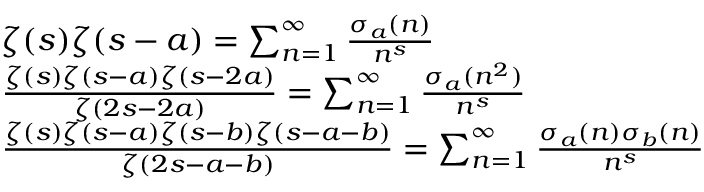<formula> <loc_0><loc_0><loc_500><loc_500>{ \begin{array} { r l } & { \zeta ( s ) \zeta ( s - a ) = \sum _ { n = 1 } ^ { \infty } { \frac { \sigma _ { a } ( n ) } { n ^ { s } } } } \\ & { { \frac { \zeta ( s ) \zeta ( s - a ) \zeta ( s - 2 a ) } { \zeta ( 2 s - 2 a ) } } = \sum _ { n = 1 } ^ { \infty } { \frac { \sigma _ { a } ( n ^ { 2 } ) } { n ^ { s } } } } \\ & { { \frac { \zeta ( s ) \zeta ( s - a ) \zeta ( s - b ) \zeta ( s - a - b ) } { \zeta ( 2 s - a - b ) } } = \sum _ { n = 1 } ^ { \infty } { \frac { \sigma _ { a } ( n ) \sigma _ { b } ( n ) } { n ^ { s } } } } \end{array} }</formula> 